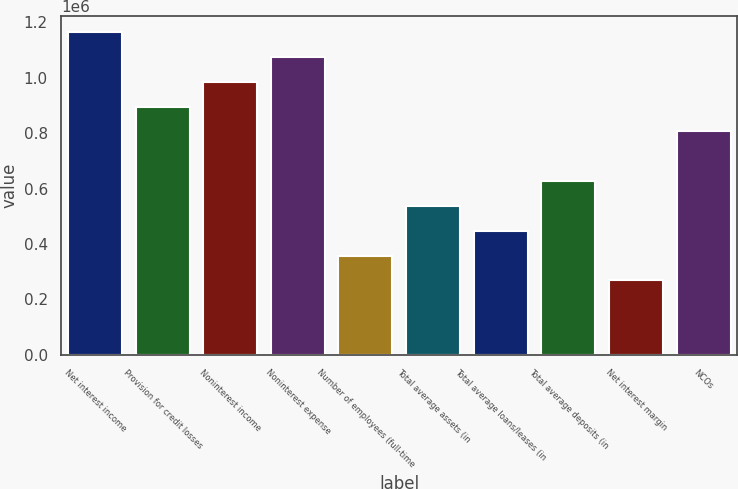Convert chart to OTSL. <chart><loc_0><loc_0><loc_500><loc_500><bar_chart><fcel>Net interest income<fcel>Provision for credit losses<fcel>Noninterest income<fcel>Noninterest expense<fcel>Number of employees (full-time<fcel>Total average assets (in<fcel>Total average loans/leases (in<fcel>Total average deposits (in<fcel>Net interest margin<fcel>NCOs<nl><fcel>1.16534e+06<fcel>896412<fcel>986053<fcel>1.07569e+06<fcel>358565<fcel>537848<fcel>448207<fcel>627489<fcel>268924<fcel>806771<nl></chart> 